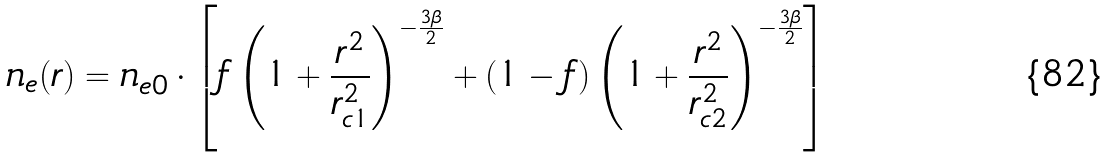<formula> <loc_0><loc_0><loc_500><loc_500>n _ { e } ( r ) = n _ { e 0 } \cdot \left [ f \left ( 1 + \frac { r ^ { 2 } } { r _ { c 1 } ^ { 2 } } \right ) ^ { - \frac { 3 \beta } { 2 } } + ( 1 - f ) \left ( 1 + \frac { r ^ { 2 } } { r _ { c 2 } ^ { 2 } } \right ) ^ { - \frac { 3 \beta } { 2 } } \right ]</formula> 